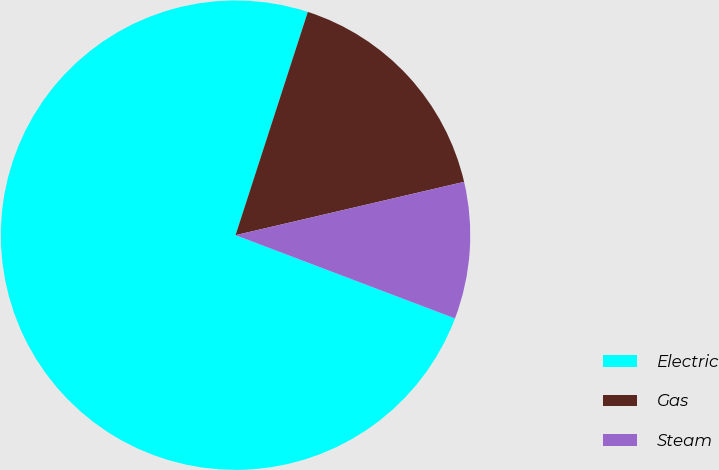Convert chart. <chart><loc_0><loc_0><loc_500><loc_500><pie_chart><fcel>Electric<fcel>Gas<fcel>Steam<nl><fcel>74.22%<fcel>16.37%<fcel>9.42%<nl></chart> 